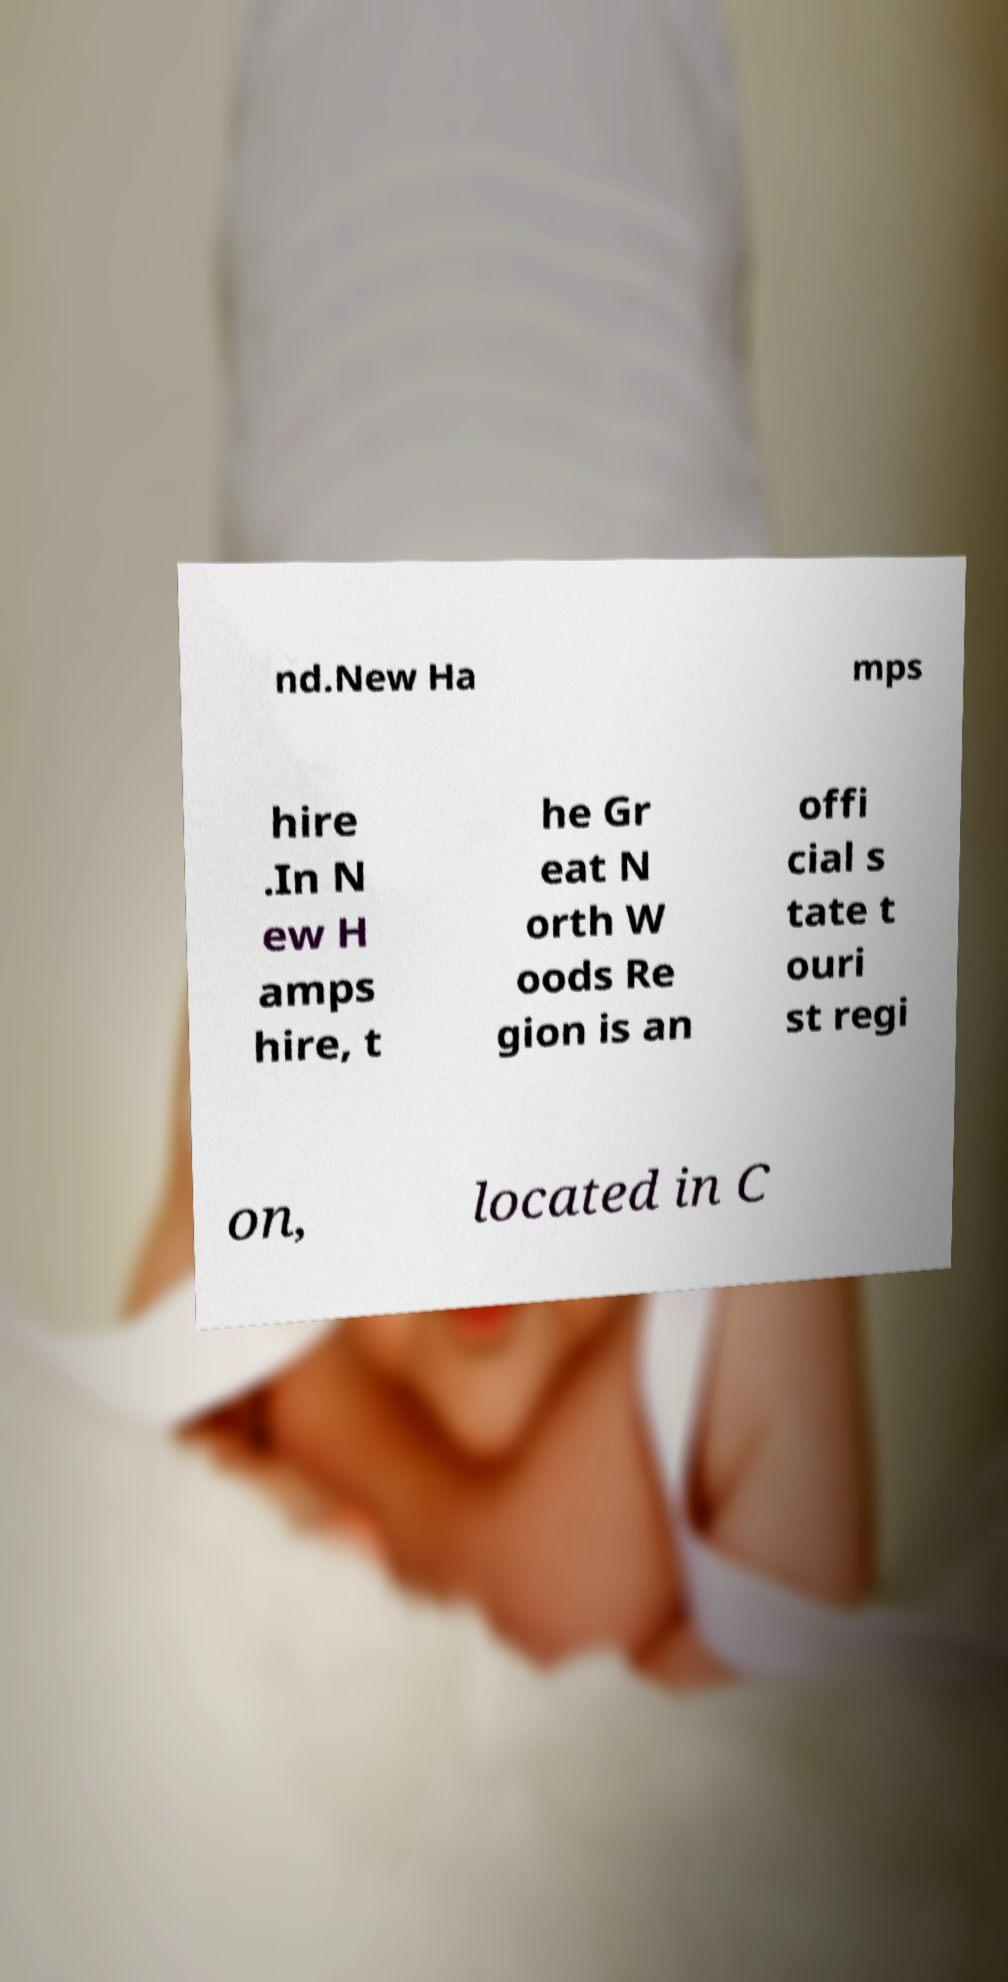Can you accurately transcribe the text from the provided image for me? nd.New Ha mps hire .In N ew H amps hire, t he Gr eat N orth W oods Re gion is an offi cial s tate t ouri st regi on, located in C 